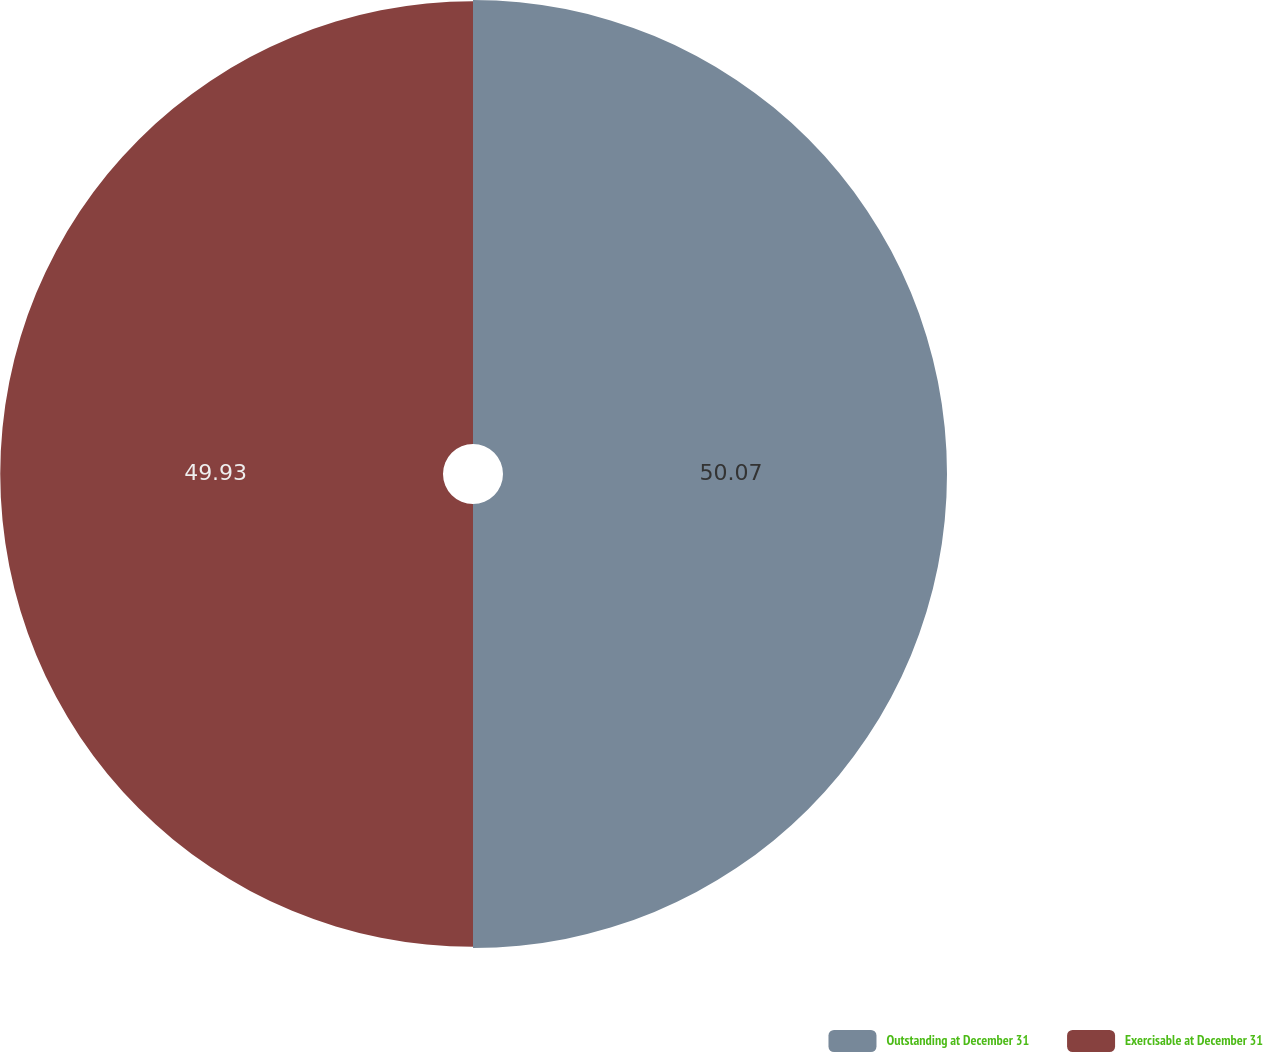Convert chart. <chart><loc_0><loc_0><loc_500><loc_500><pie_chart><fcel>Outstanding at December 31<fcel>Exercisable at December 31<nl><fcel>50.07%<fcel>49.93%<nl></chart> 